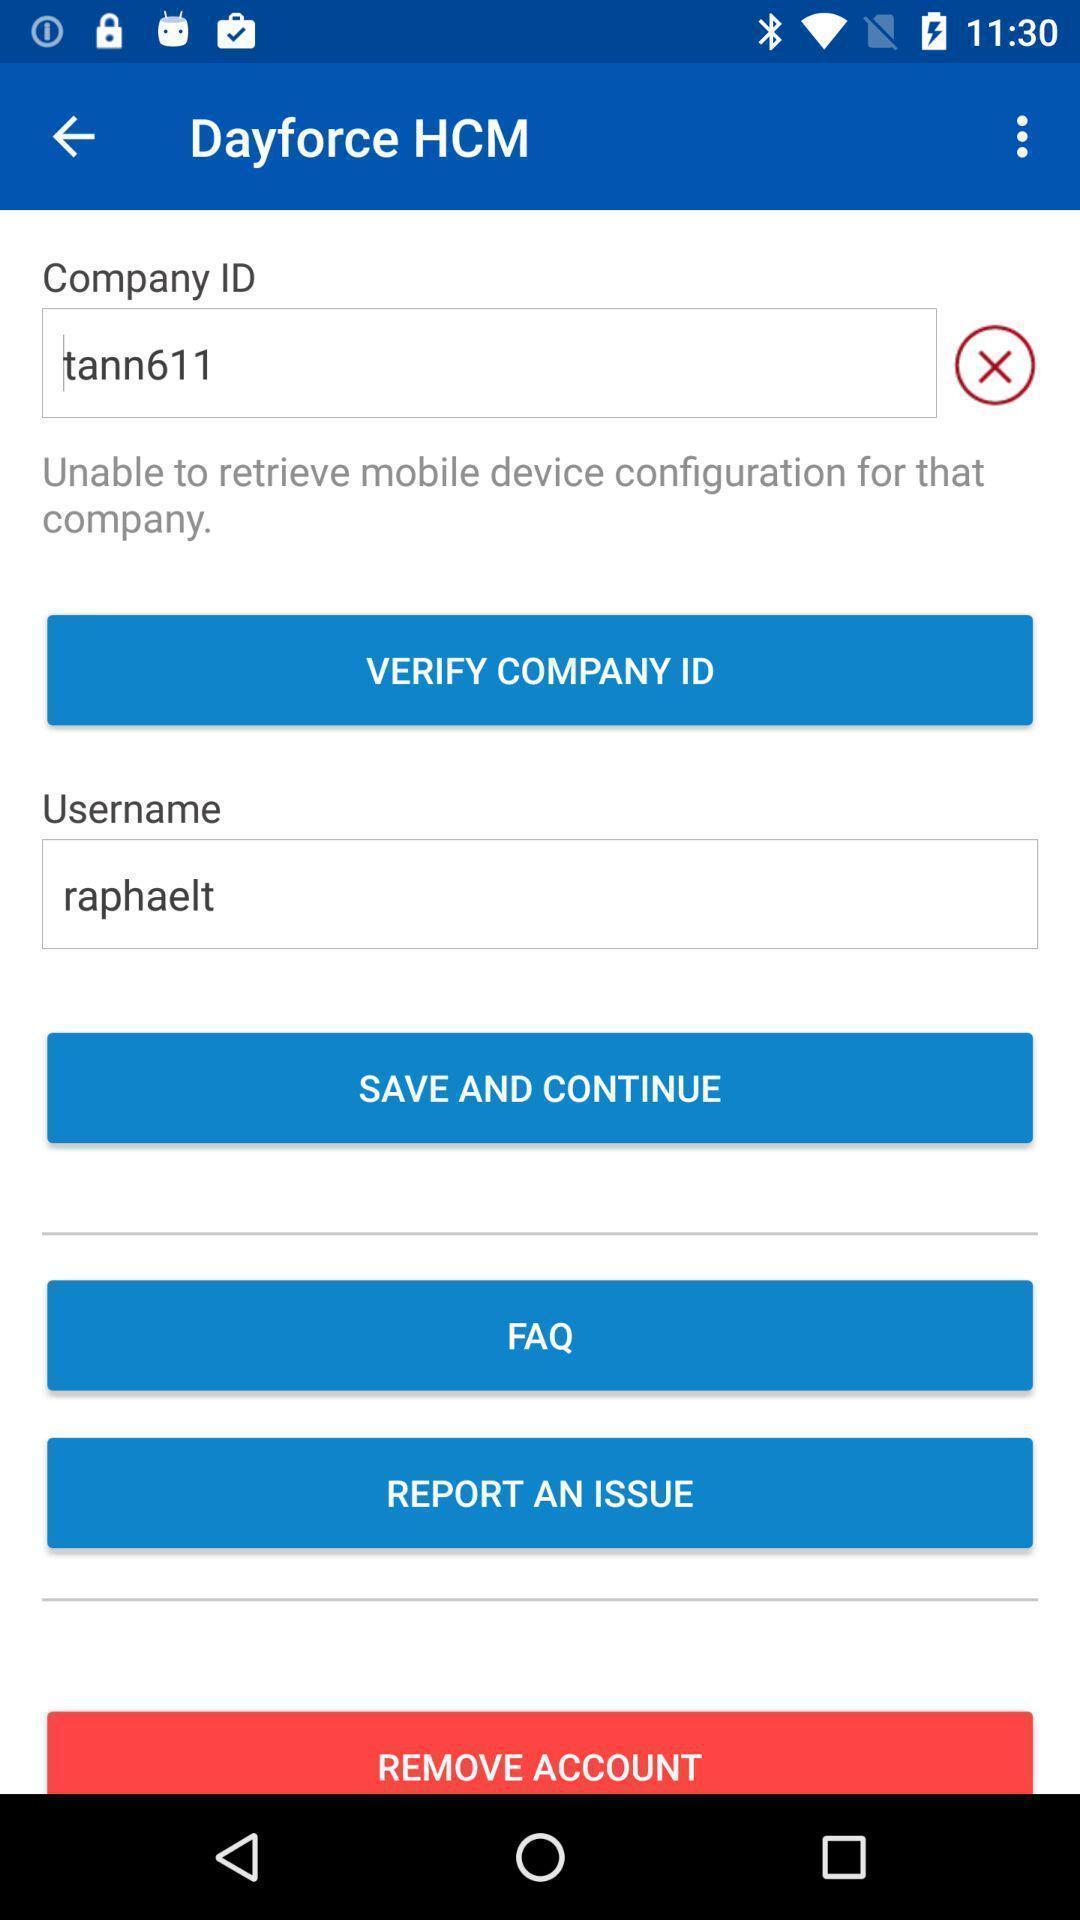Provide a description of this screenshot. Profile details displaying in this image. 